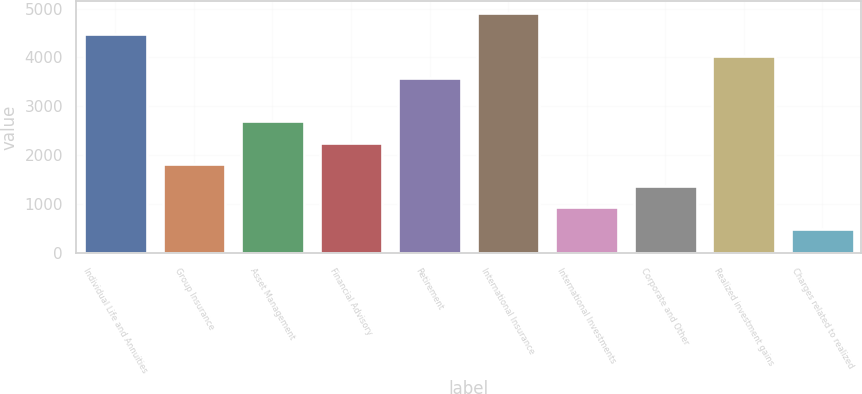<chart> <loc_0><loc_0><loc_500><loc_500><bar_chart><fcel>Individual Life and Annuities<fcel>Group Insurance<fcel>Asset Management<fcel>Financial Advisory<fcel>Retirement<fcel>International Insurance<fcel>International Investments<fcel>Corporate and Other<fcel>Realized investment gains<fcel>Charges related to realized<nl><fcel>4471<fcel>1818.4<fcel>2702.6<fcel>2260.5<fcel>3586.8<fcel>4913.1<fcel>934.2<fcel>1376.3<fcel>4028.9<fcel>492.1<nl></chart> 